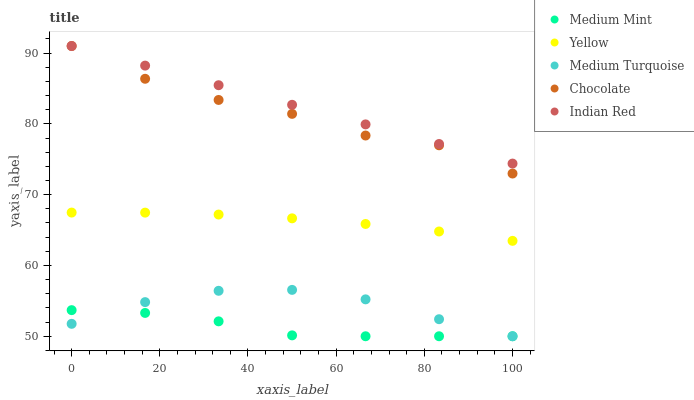Does Medium Mint have the minimum area under the curve?
Answer yes or no. Yes. Does Indian Red have the maximum area under the curve?
Answer yes or no. Yes. Does Medium Turquoise have the minimum area under the curve?
Answer yes or no. No. Does Medium Turquoise have the maximum area under the curve?
Answer yes or no. No. Is Indian Red the smoothest?
Answer yes or no. Yes. Is Chocolate the roughest?
Answer yes or no. Yes. Is Medium Turquoise the smoothest?
Answer yes or no. No. Is Medium Turquoise the roughest?
Answer yes or no. No. Does Medium Mint have the lowest value?
Answer yes or no. Yes. Does Indian Red have the lowest value?
Answer yes or no. No. Does Chocolate have the highest value?
Answer yes or no. Yes. Does Medium Turquoise have the highest value?
Answer yes or no. No. Is Medium Mint less than Indian Red?
Answer yes or no. Yes. Is Chocolate greater than Medium Mint?
Answer yes or no. Yes. Does Medium Mint intersect Medium Turquoise?
Answer yes or no. Yes. Is Medium Mint less than Medium Turquoise?
Answer yes or no. No. Is Medium Mint greater than Medium Turquoise?
Answer yes or no. No. Does Medium Mint intersect Indian Red?
Answer yes or no. No. 